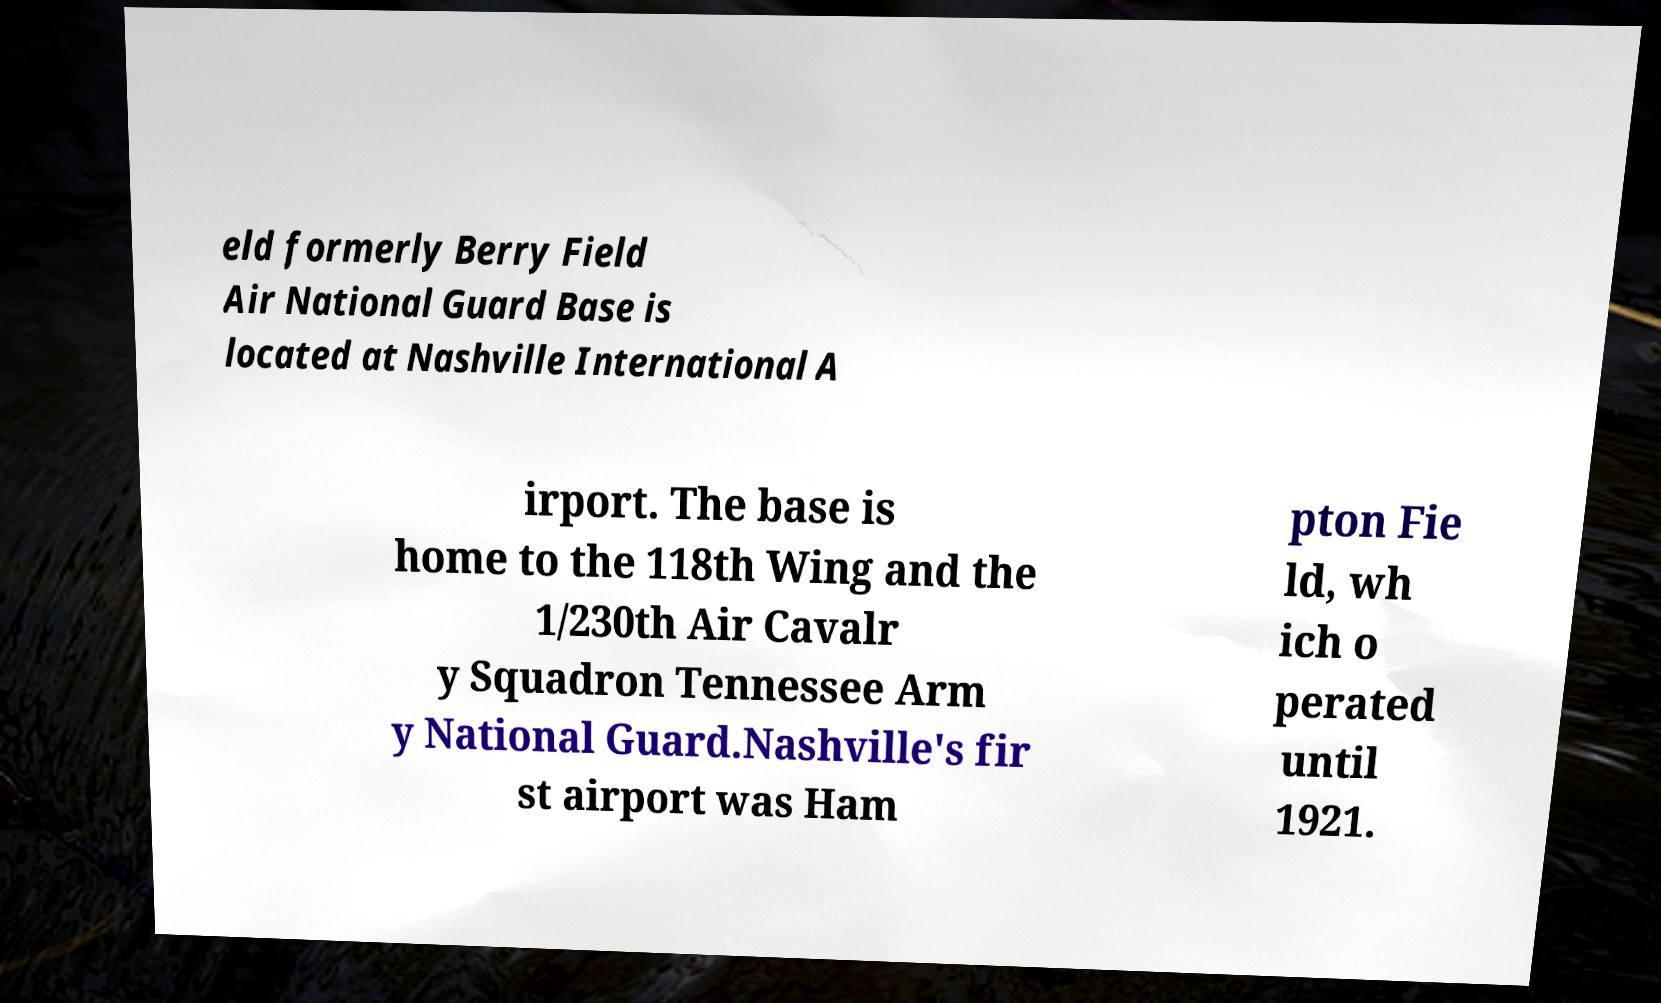Could you extract and type out the text from this image? eld formerly Berry Field Air National Guard Base is located at Nashville International A irport. The base is home to the 118th Wing and the 1/230th Air Cavalr y Squadron Tennessee Arm y National Guard.Nashville's fir st airport was Ham pton Fie ld, wh ich o perated until 1921. 